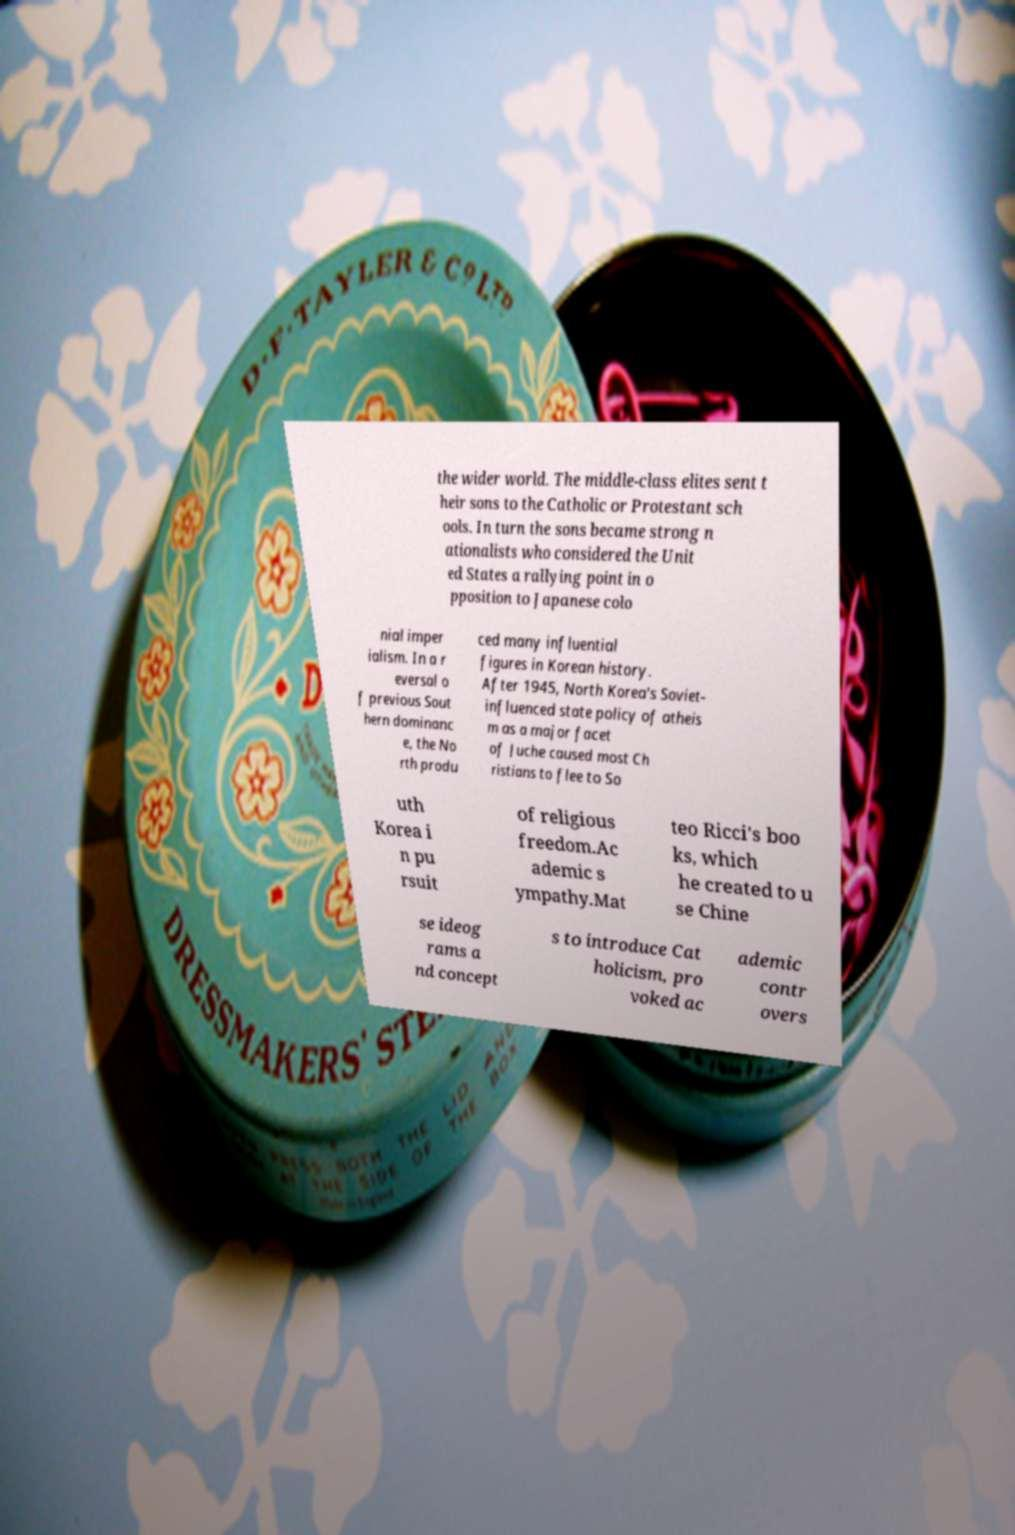Can you accurately transcribe the text from the provided image for me? the wider world. The middle-class elites sent t heir sons to the Catholic or Protestant sch ools. In turn the sons became strong n ationalists who considered the Unit ed States a rallying point in o pposition to Japanese colo nial imper ialism. In a r eversal o f previous Sout hern dominanc e, the No rth produ ced many influential figures in Korean history. After 1945, North Korea's Soviet- influenced state policy of atheis m as a major facet of Juche caused most Ch ristians to flee to So uth Korea i n pu rsuit of religious freedom.Ac ademic s ympathy.Mat teo Ricci's boo ks, which he created to u se Chine se ideog rams a nd concept s to introduce Cat holicism, pro voked ac ademic contr overs 